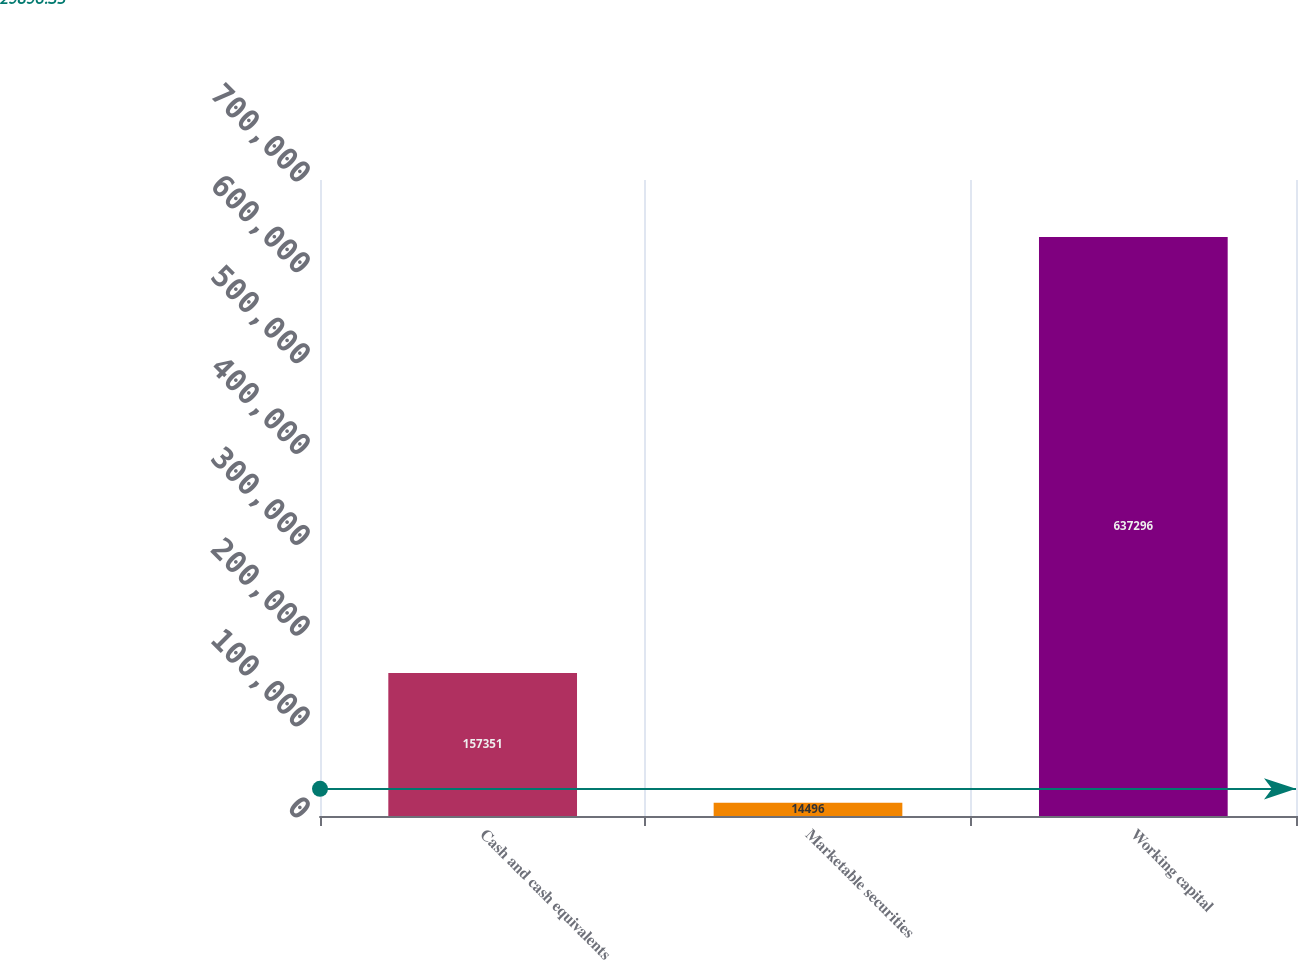Convert chart to OTSL. <chart><loc_0><loc_0><loc_500><loc_500><bar_chart><fcel>Cash and cash equivalents<fcel>Marketable securities<fcel>Working capital<nl><fcel>157351<fcel>14496<fcel>637296<nl></chart> 